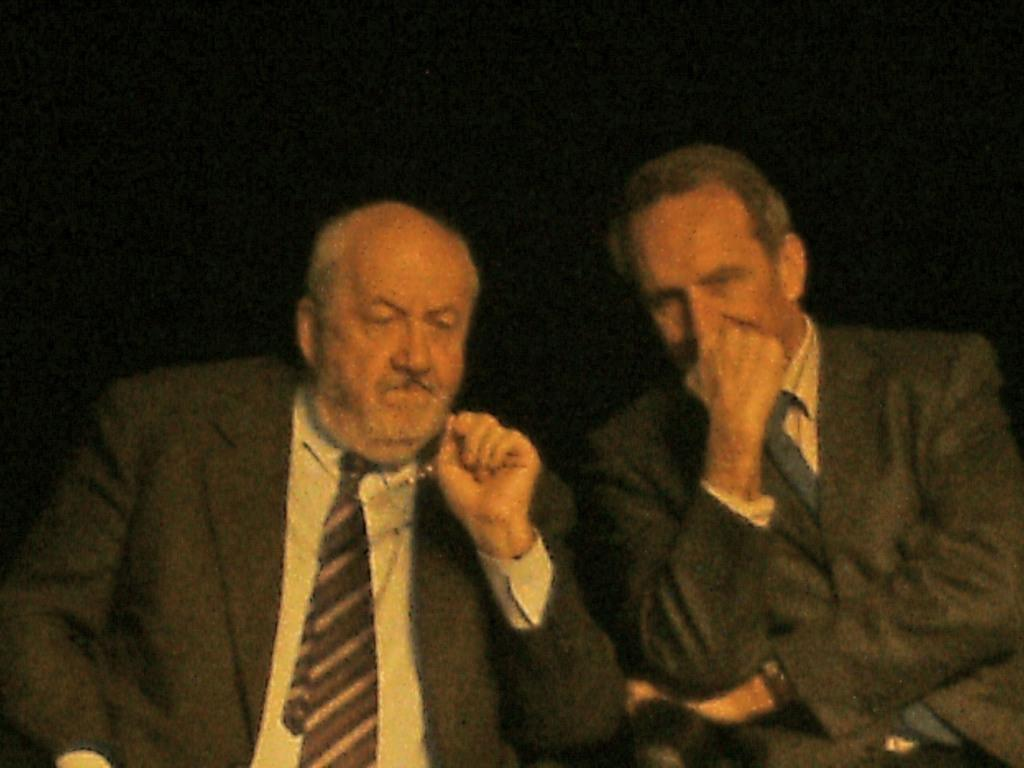How many people are sitting in the image? There are two people sitting in the image. What can be seen in the background of the image? The background of the image is black. What type of houses do the people in the image own? There is no information about houses or ownership in the image. What kind of experience do the people in the image have? There is no information about the people's experiences in the image. 